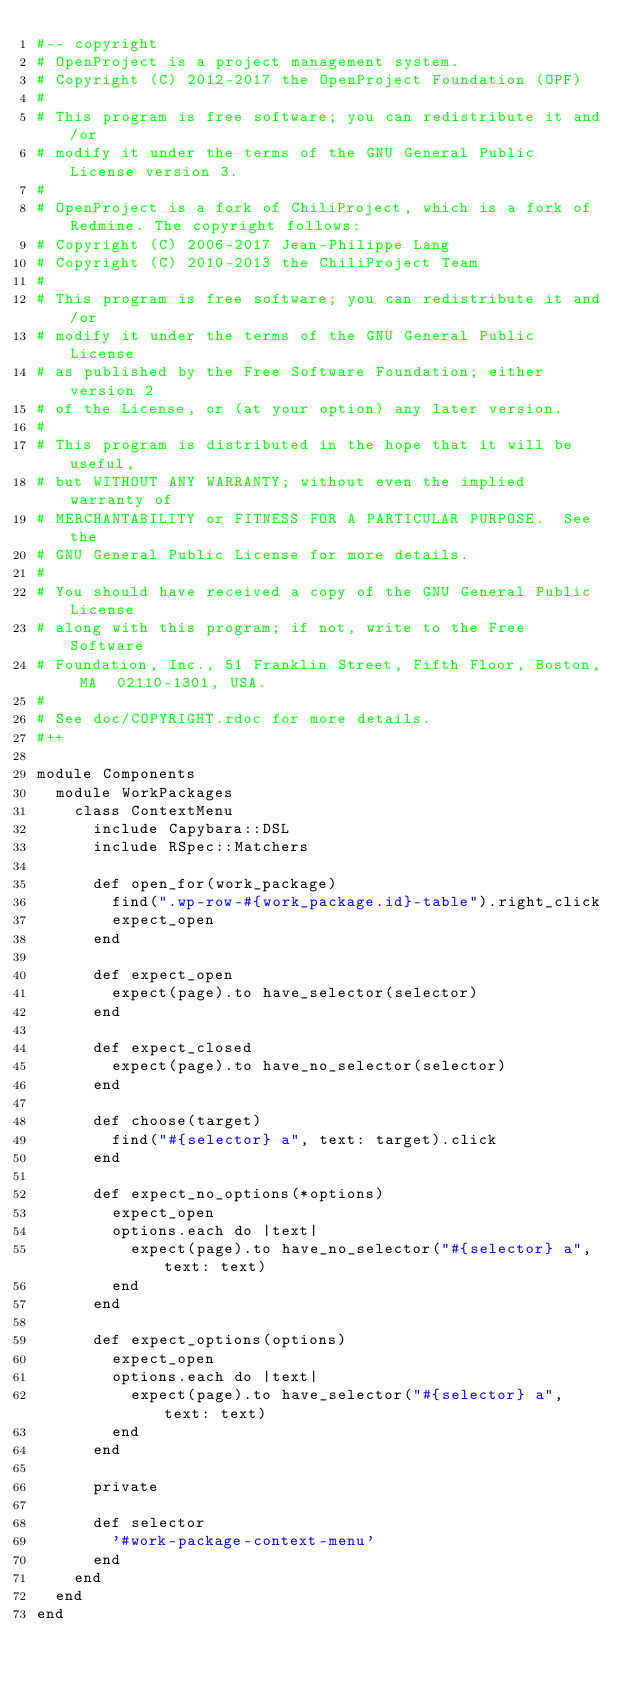<code> <loc_0><loc_0><loc_500><loc_500><_Ruby_>#-- copyright
# OpenProject is a project management system.
# Copyright (C) 2012-2017 the OpenProject Foundation (OPF)
#
# This program is free software; you can redistribute it and/or
# modify it under the terms of the GNU General Public License version 3.
#
# OpenProject is a fork of ChiliProject, which is a fork of Redmine. The copyright follows:
# Copyright (C) 2006-2017 Jean-Philippe Lang
# Copyright (C) 2010-2013 the ChiliProject Team
#
# This program is free software; you can redistribute it and/or
# modify it under the terms of the GNU General Public License
# as published by the Free Software Foundation; either version 2
# of the License, or (at your option) any later version.
#
# This program is distributed in the hope that it will be useful,
# but WITHOUT ANY WARRANTY; without even the implied warranty of
# MERCHANTABILITY or FITNESS FOR A PARTICULAR PURPOSE.  See the
# GNU General Public License for more details.
#
# You should have received a copy of the GNU General Public License
# along with this program; if not, write to the Free Software
# Foundation, Inc., 51 Franklin Street, Fifth Floor, Boston, MA  02110-1301, USA.
#
# See doc/COPYRIGHT.rdoc for more details.
#++

module Components
  module WorkPackages
    class ContextMenu
      include Capybara::DSL
      include RSpec::Matchers

      def open_for(work_package)
        find(".wp-row-#{work_package.id}-table").right_click
        expect_open
      end

      def expect_open
        expect(page).to have_selector(selector)
      end

      def expect_closed
        expect(page).to have_no_selector(selector)
      end

      def choose(target)
        find("#{selector} a", text: target).click
      end

      def expect_no_options(*options)
        expect_open
        options.each do |text|
          expect(page).to have_no_selector("#{selector} a", text: text)
        end
      end

      def expect_options(options)
        expect_open
        options.each do |text|
          expect(page).to have_selector("#{selector} a", text: text)
        end
      end

      private

      def selector
        '#work-package-context-menu'
      end
    end
  end
end
</code> 